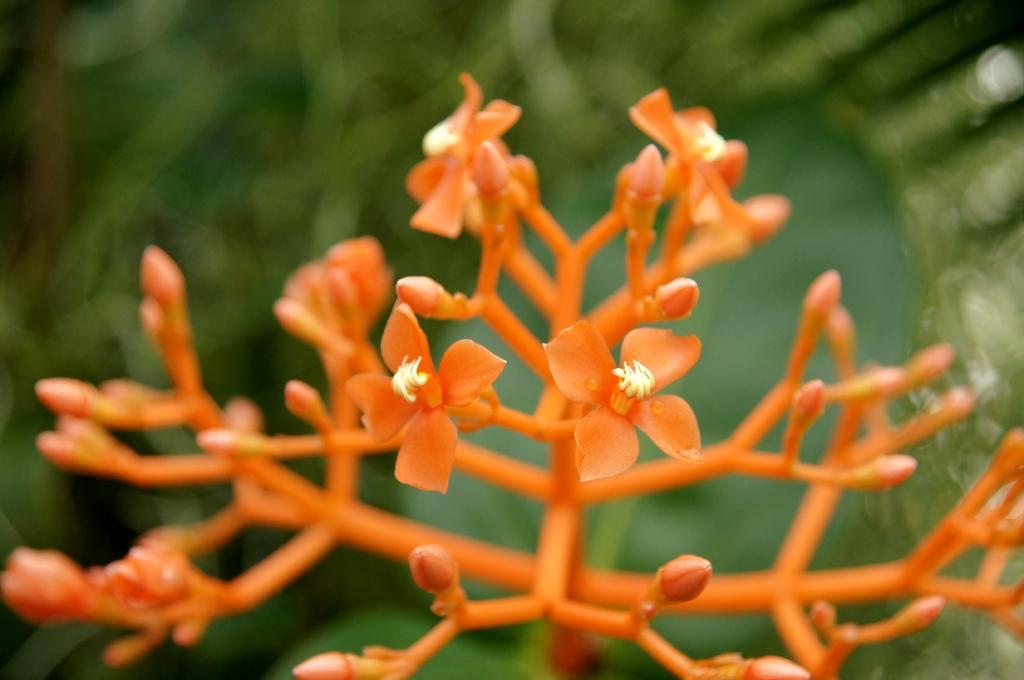What color are the flowers on the plant in the image? The flowers on the plant in the image are orange color. What other features can be seen on the plant? The plant has flower buds. Are there any other plants visible in the image? Yes, there are green color plants behind the orange plant, but they are not clearly visible. What is the name of the road where the orange plant is located in the image? There is no road visible in the image, and the location of the plant is not mentioned. How many apples are hanging from the orange plant in the image? There are no apples present in the image; the plant has orange color flowers and flower buds. 